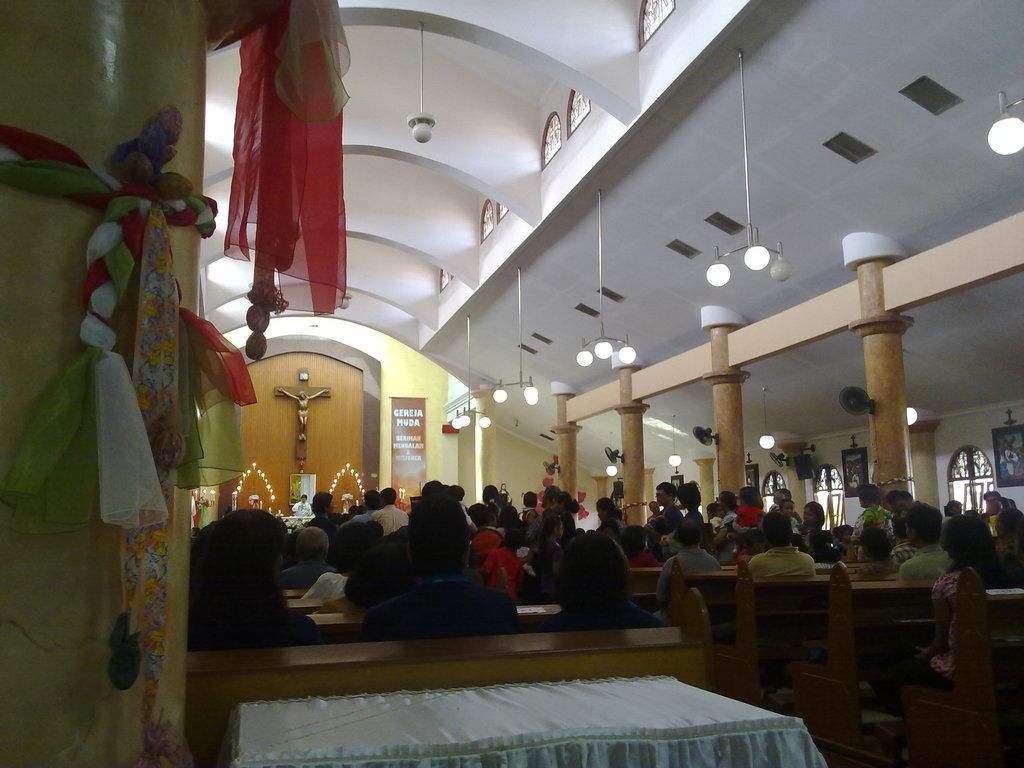What can be seen in the image? There are people, pillars, walls, frames, lights, decorative objects, table fans, and a banner in the image. What are the people in the image doing? Some people are sitting on benches in the image. Can you describe the architectural features in the image? There are pillars and walls in the image. What type of lighting is present in the image? There are lights in the image. Are there any decorative elements in the image? Yes, there are decorative objects in the image. What type of cooling device is present in the image? There are table fans in the image. What is hanging from the ceiling in the image? There is a banner hanging from the ceiling in the image. What type of zephyr is blowing through the image? There is no mention of a zephyr in the image, as it is a meteorological term for a gentle breeze, which is not visible in the image. What type of beef dish is being served in the image? There is no mention of food, specifically beef, in the image. 